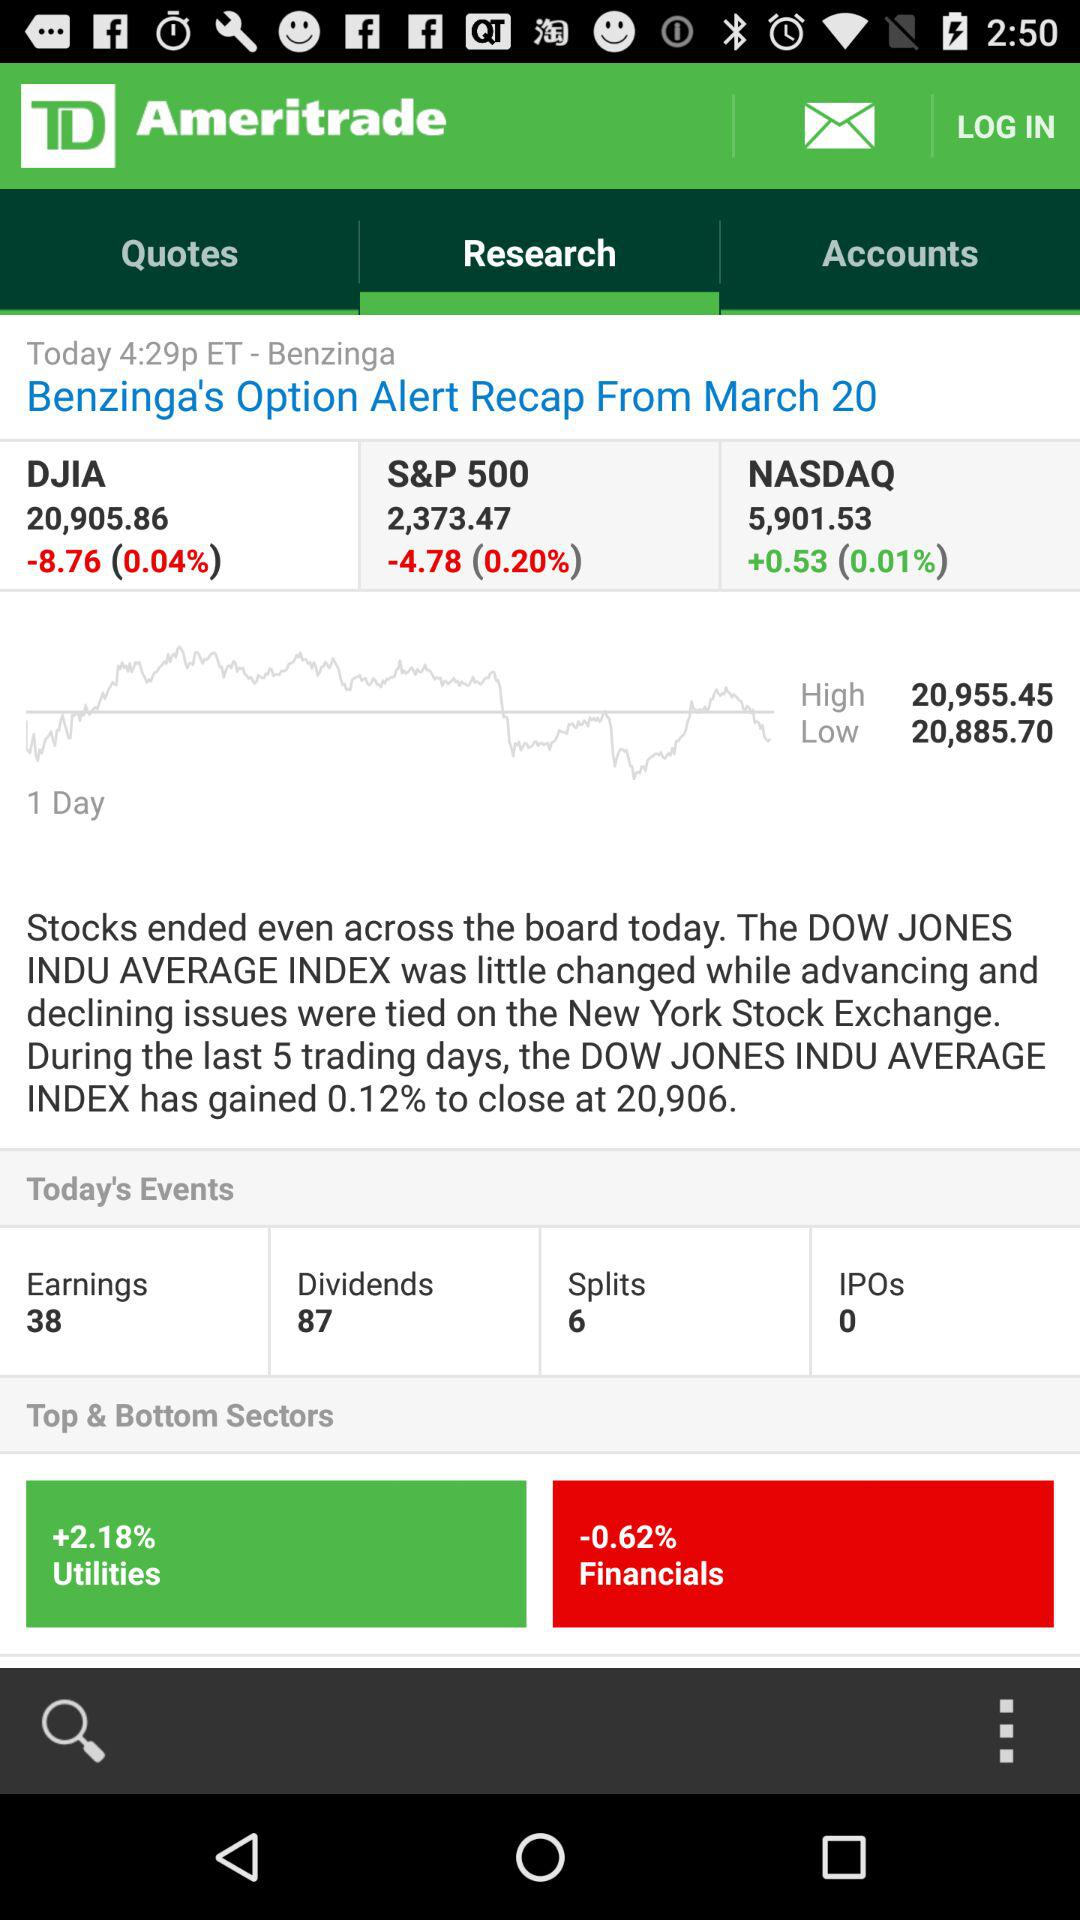What is the number of splits? The number of splits is 6. 